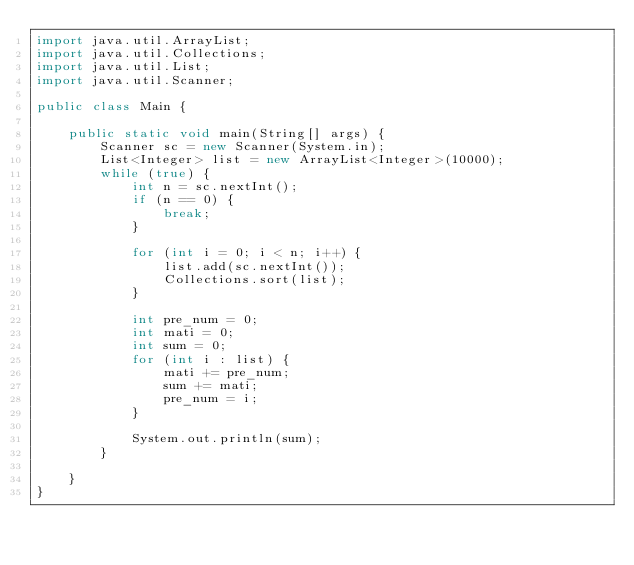Convert code to text. <code><loc_0><loc_0><loc_500><loc_500><_Java_>import java.util.ArrayList;
import java.util.Collections;
import java.util.List;
import java.util.Scanner;

public class Main {

	public static void main(String[] args) {
		Scanner sc = new Scanner(System.in);
		List<Integer> list = new ArrayList<Integer>(10000);
		while (true) {
			int n = sc.nextInt();
			if (n == 0) {
				break;
			}

			for (int i = 0; i < n; i++) {
				list.add(sc.nextInt());
				Collections.sort(list);
			}

			int pre_num = 0;
			int mati = 0;
			int sum = 0;
			for (int i : list) {
				mati += pre_num;
				sum += mati;
				pre_num = i;
			}

			System.out.println(sum);
		}

	}
}</code> 